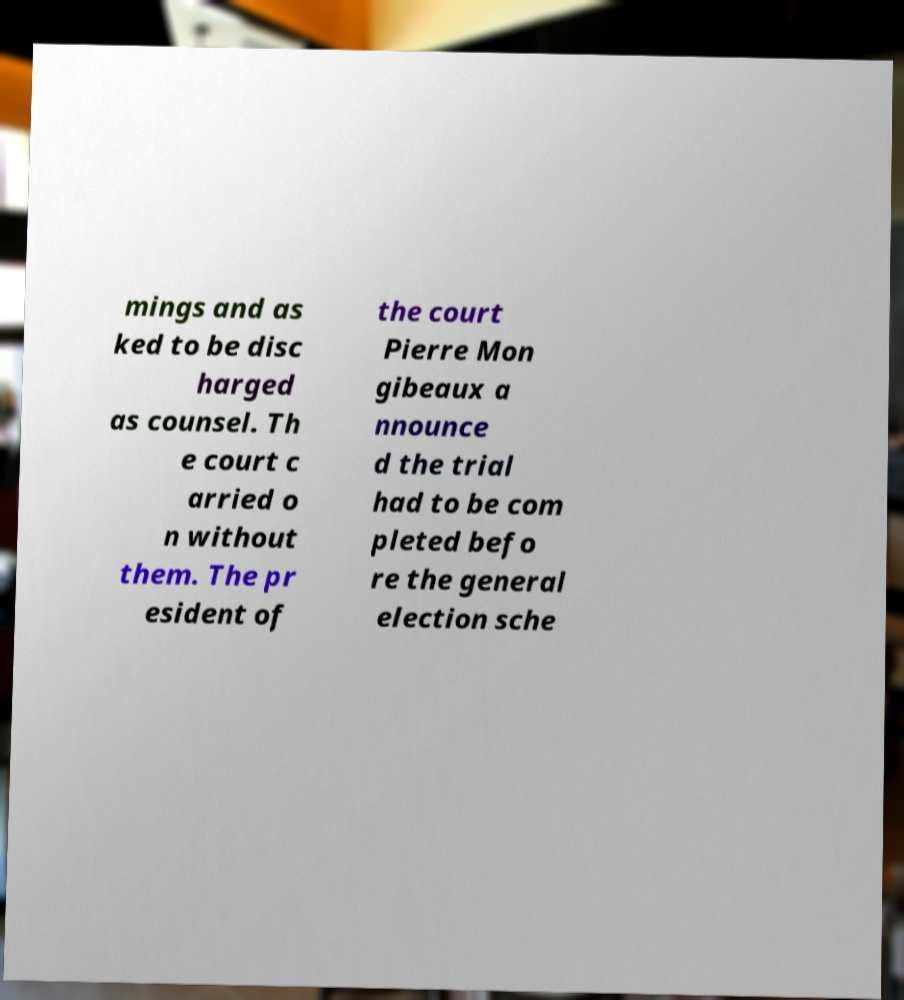For documentation purposes, I need the text within this image transcribed. Could you provide that? mings and as ked to be disc harged as counsel. Th e court c arried o n without them. The pr esident of the court Pierre Mon gibeaux a nnounce d the trial had to be com pleted befo re the general election sche 